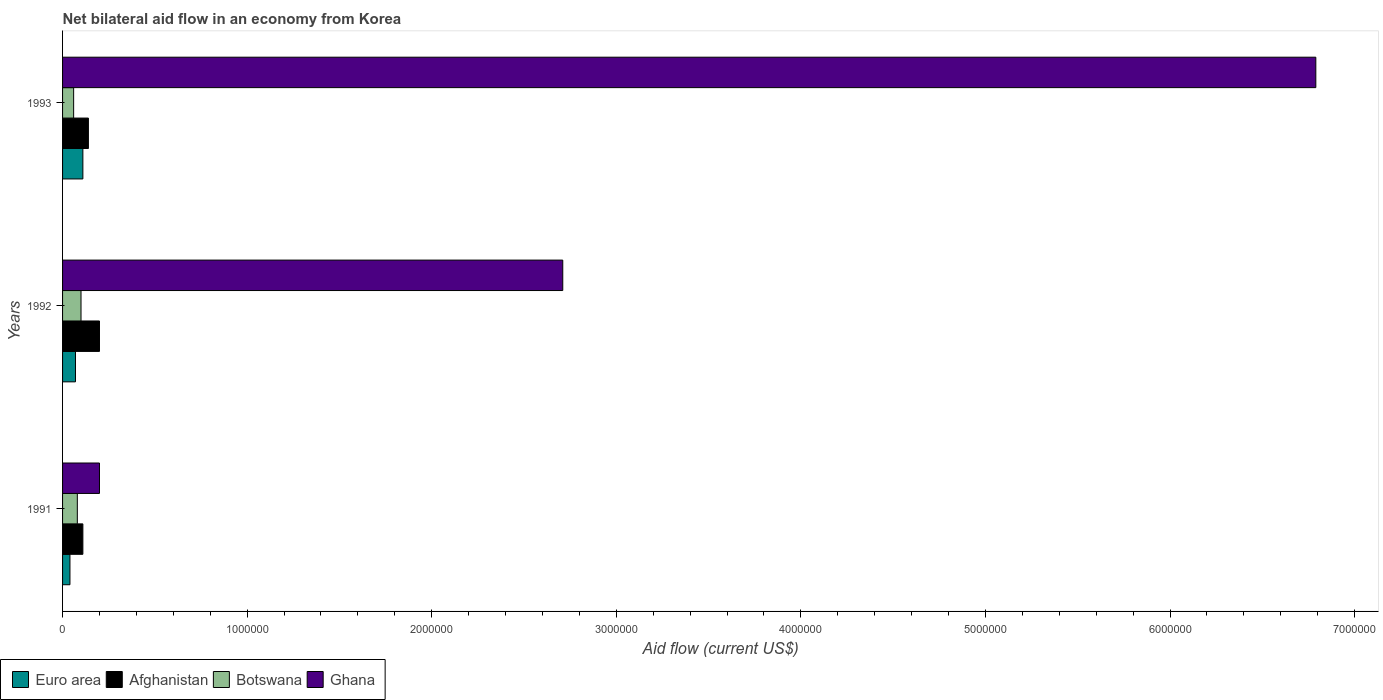How many different coloured bars are there?
Your response must be concise. 4. Are the number of bars per tick equal to the number of legend labels?
Your response must be concise. Yes. How many bars are there on the 1st tick from the top?
Ensure brevity in your answer.  4. What is the label of the 2nd group of bars from the top?
Offer a terse response. 1992. What is the net bilateral aid flow in Afghanistan in 1992?
Ensure brevity in your answer.  2.00e+05. Across all years, what is the maximum net bilateral aid flow in Euro area?
Your answer should be very brief. 1.10e+05. In which year was the net bilateral aid flow in Euro area maximum?
Offer a very short reply. 1993. What is the total net bilateral aid flow in Botswana in the graph?
Offer a terse response. 2.40e+05. What is the difference between the net bilateral aid flow in Botswana in 1992 and the net bilateral aid flow in Euro area in 1991?
Your answer should be very brief. 6.00e+04. In the year 1992, what is the difference between the net bilateral aid flow in Ghana and net bilateral aid flow in Afghanistan?
Your answer should be compact. 2.51e+06. In how many years, is the net bilateral aid flow in Ghana greater than 1400000 US$?
Your answer should be compact. 2. What is the ratio of the net bilateral aid flow in Afghanistan in 1992 to that in 1993?
Offer a terse response. 1.43. Is the difference between the net bilateral aid flow in Ghana in 1991 and 1993 greater than the difference between the net bilateral aid flow in Afghanistan in 1991 and 1993?
Your answer should be compact. No. What is the difference between the highest and the lowest net bilateral aid flow in Ghana?
Provide a succinct answer. 6.59e+06. In how many years, is the net bilateral aid flow in Botswana greater than the average net bilateral aid flow in Botswana taken over all years?
Ensure brevity in your answer.  1. Is it the case that in every year, the sum of the net bilateral aid flow in Euro area and net bilateral aid flow in Botswana is greater than the sum of net bilateral aid flow in Afghanistan and net bilateral aid flow in Ghana?
Make the answer very short. No. What does the 4th bar from the top in 1993 represents?
Give a very brief answer. Euro area. What does the 2nd bar from the bottom in 1993 represents?
Give a very brief answer. Afghanistan. Is it the case that in every year, the sum of the net bilateral aid flow in Botswana and net bilateral aid flow in Afghanistan is greater than the net bilateral aid flow in Ghana?
Offer a terse response. No. How many bars are there?
Give a very brief answer. 12. How many years are there in the graph?
Provide a short and direct response. 3. What is the difference between two consecutive major ticks on the X-axis?
Provide a short and direct response. 1.00e+06. Are the values on the major ticks of X-axis written in scientific E-notation?
Give a very brief answer. No. Does the graph contain grids?
Your response must be concise. No. Where does the legend appear in the graph?
Provide a succinct answer. Bottom left. How are the legend labels stacked?
Offer a terse response. Horizontal. What is the title of the graph?
Ensure brevity in your answer.  Net bilateral aid flow in an economy from Korea. What is the Aid flow (current US$) of Euro area in 1991?
Your answer should be compact. 4.00e+04. What is the Aid flow (current US$) of Afghanistan in 1991?
Give a very brief answer. 1.10e+05. What is the Aid flow (current US$) of Botswana in 1991?
Provide a succinct answer. 8.00e+04. What is the Aid flow (current US$) in Afghanistan in 1992?
Provide a succinct answer. 2.00e+05. What is the Aid flow (current US$) of Botswana in 1992?
Your answer should be very brief. 1.00e+05. What is the Aid flow (current US$) of Ghana in 1992?
Offer a very short reply. 2.71e+06. What is the Aid flow (current US$) in Afghanistan in 1993?
Make the answer very short. 1.40e+05. What is the Aid flow (current US$) of Botswana in 1993?
Keep it short and to the point. 6.00e+04. What is the Aid flow (current US$) in Ghana in 1993?
Provide a succinct answer. 6.79e+06. Across all years, what is the maximum Aid flow (current US$) of Afghanistan?
Provide a succinct answer. 2.00e+05. Across all years, what is the maximum Aid flow (current US$) in Ghana?
Make the answer very short. 6.79e+06. Across all years, what is the minimum Aid flow (current US$) in Afghanistan?
Make the answer very short. 1.10e+05. Across all years, what is the minimum Aid flow (current US$) of Ghana?
Provide a short and direct response. 2.00e+05. What is the total Aid flow (current US$) of Afghanistan in the graph?
Keep it short and to the point. 4.50e+05. What is the total Aid flow (current US$) in Botswana in the graph?
Keep it short and to the point. 2.40e+05. What is the total Aid flow (current US$) of Ghana in the graph?
Provide a succinct answer. 9.70e+06. What is the difference between the Aid flow (current US$) in Euro area in 1991 and that in 1992?
Make the answer very short. -3.00e+04. What is the difference between the Aid flow (current US$) in Afghanistan in 1991 and that in 1992?
Make the answer very short. -9.00e+04. What is the difference between the Aid flow (current US$) of Ghana in 1991 and that in 1992?
Offer a terse response. -2.51e+06. What is the difference between the Aid flow (current US$) in Afghanistan in 1991 and that in 1993?
Make the answer very short. -3.00e+04. What is the difference between the Aid flow (current US$) in Ghana in 1991 and that in 1993?
Give a very brief answer. -6.59e+06. What is the difference between the Aid flow (current US$) of Euro area in 1992 and that in 1993?
Your answer should be very brief. -4.00e+04. What is the difference between the Aid flow (current US$) in Afghanistan in 1992 and that in 1993?
Keep it short and to the point. 6.00e+04. What is the difference between the Aid flow (current US$) of Botswana in 1992 and that in 1993?
Provide a short and direct response. 4.00e+04. What is the difference between the Aid flow (current US$) in Ghana in 1992 and that in 1993?
Provide a short and direct response. -4.08e+06. What is the difference between the Aid flow (current US$) in Euro area in 1991 and the Aid flow (current US$) in Ghana in 1992?
Keep it short and to the point. -2.67e+06. What is the difference between the Aid flow (current US$) in Afghanistan in 1991 and the Aid flow (current US$) in Botswana in 1992?
Make the answer very short. 10000. What is the difference between the Aid flow (current US$) in Afghanistan in 1991 and the Aid flow (current US$) in Ghana in 1992?
Offer a very short reply. -2.60e+06. What is the difference between the Aid flow (current US$) in Botswana in 1991 and the Aid flow (current US$) in Ghana in 1992?
Your answer should be compact. -2.63e+06. What is the difference between the Aid flow (current US$) of Euro area in 1991 and the Aid flow (current US$) of Botswana in 1993?
Provide a succinct answer. -2.00e+04. What is the difference between the Aid flow (current US$) in Euro area in 1991 and the Aid flow (current US$) in Ghana in 1993?
Your answer should be compact. -6.75e+06. What is the difference between the Aid flow (current US$) in Afghanistan in 1991 and the Aid flow (current US$) in Ghana in 1993?
Ensure brevity in your answer.  -6.68e+06. What is the difference between the Aid flow (current US$) in Botswana in 1991 and the Aid flow (current US$) in Ghana in 1993?
Provide a short and direct response. -6.71e+06. What is the difference between the Aid flow (current US$) of Euro area in 1992 and the Aid flow (current US$) of Afghanistan in 1993?
Give a very brief answer. -7.00e+04. What is the difference between the Aid flow (current US$) of Euro area in 1992 and the Aid flow (current US$) of Ghana in 1993?
Give a very brief answer. -6.72e+06. What is the difference between the Aid flow (current US$) of Afghanistan in 1992 and the Aid flow (current US$) of Ghana in 1993?
Your answer should be compact. -6.59e+06. What is the difference between the Aid flow (current US$) in Botswana in 1992 and the Aid flow (current US$) in Ghana in 1993?
Make the answer very short. -6.69e+06. What is the average Aid flow (current US$) in Euro area per year?
Provide a short and direct response. 7.33e+04. What is the average Aid flow (current US$) in Ghana per year?
Provide a succinct answer. 3.23e+06. In the year 1991, what is the difference between the Aid flow (current US$) of Euro area and Aid flow (current US$) of Botswana?
Ensure brevity in your answer.  -4.00e+04. In the year 1991, what is the difference between the Aid flow (current US$) of Botswana and Aid flow (current US$) of Ghana?
Offer a terse response. -1.20e+05. In the year 1992, what is the difference between the Aid flow (current US$) in Euro area and Aid flow (current US$) in Ghana?
Keep it short and to the point. -2.64e+06. In the year 1992, what is the difference between the Aid flow (current US$) in Afghanistan and Aid flow (current US$) in Ghana?
Your response must be concise. -2.51e+06. In the year 1992, what is the difference between the Aid flow (current US$) in Botswana and Aid flow (current US$) in Ghana?
Your answer should be compact. -2.61e+06. In the year 1993, what is the difference between the Aid flow (current US$) in Euro area and Aid flow (current US$) in Botswana?
Give a very brief answer. 5.00e+04. In the year 1993, what is the difference between the Aid flow (current US$) in Euro area and Aid flow (current US$) in Ghana?
Ensure brevity in your answer.  -6.68e+06. In the year 1993, what is the difference between the Aid flow (current US$) of Afghanistan and Aid flow (current US$) of Botswana?
Provide a short and direct response. 8.00e+04. In the year 1993, what is the difference between the Aid flow (current US$) of Afghanistan and Aid flow (current US$) of Ghana?
Give a very brief answer. -6.65e+06. In the year 1993, what is the difference between the Aid flow (current US$) of Botswana and Aid flow (current US$) of Ghana?
Offer a very short reply. -6.73e+06. What is the ratio of the Aid flow (current US$) in Euro area in 1991 to that in 1992?
Keep it short and to the point. 0.57. What is the ratio of the Aid flow (current US$) in Afghanistan in 1991 to that in 1992?
Provide a short and direct response. 0.55. What is the ratio of the Aid flow (current US$) of Botswana in 1991 to that in 1992?
Your answer should be very brief. 0.8. What is the ratio of the Aid flow (current US$) of Ghana in 1991 to that in 1992?
Give a very brief answer. 0.07. What is the ratio of the Aid flow (current US$) in Euro area in 1991 to that in 1993?
Offer a very short reply. 0.36. What is the ratio of the Aid flow (current US$) in Afghanistan in 1991 to that in 1993?
Offer a terse response. 0.79. What is the ratio of the Aid flow (current US$) in Ghana in 1991 to that in 1993?
Keep it short and to the point. 0.03. What is the ratio of the Aid flow (current US$) in Euro area in 1992 to that in 1993?
Your answer should be compact. 0.64. What is the ratio of the Aid flow (current US$) of Afghanistan in 1992 to that in 1993?
Offer a very short reply. 1.43. What is the ratio of the Aid flow (current US$) in Ghana in 1992 to that in 1993?
Ensure brevity in your answer.  0.4. What is the difference between the highest and the second highest Aid flow (current US$) in Afghanistan?
Provide a succinct answer. 6.00e+04. What is the difference between the highest and the second highest Aid flow (current US$) of Ghana?
Make the answer very short. 4.08e+06. What is the difference between the highest and the lowest Aid flow (current US$) of Euro area?
Provide a succinct answer. 7.00e+04. What is the difference between the highest and the lowest Aid flow (current US$) in Ghana?
Offer a very short reply. 6.59e+06. 